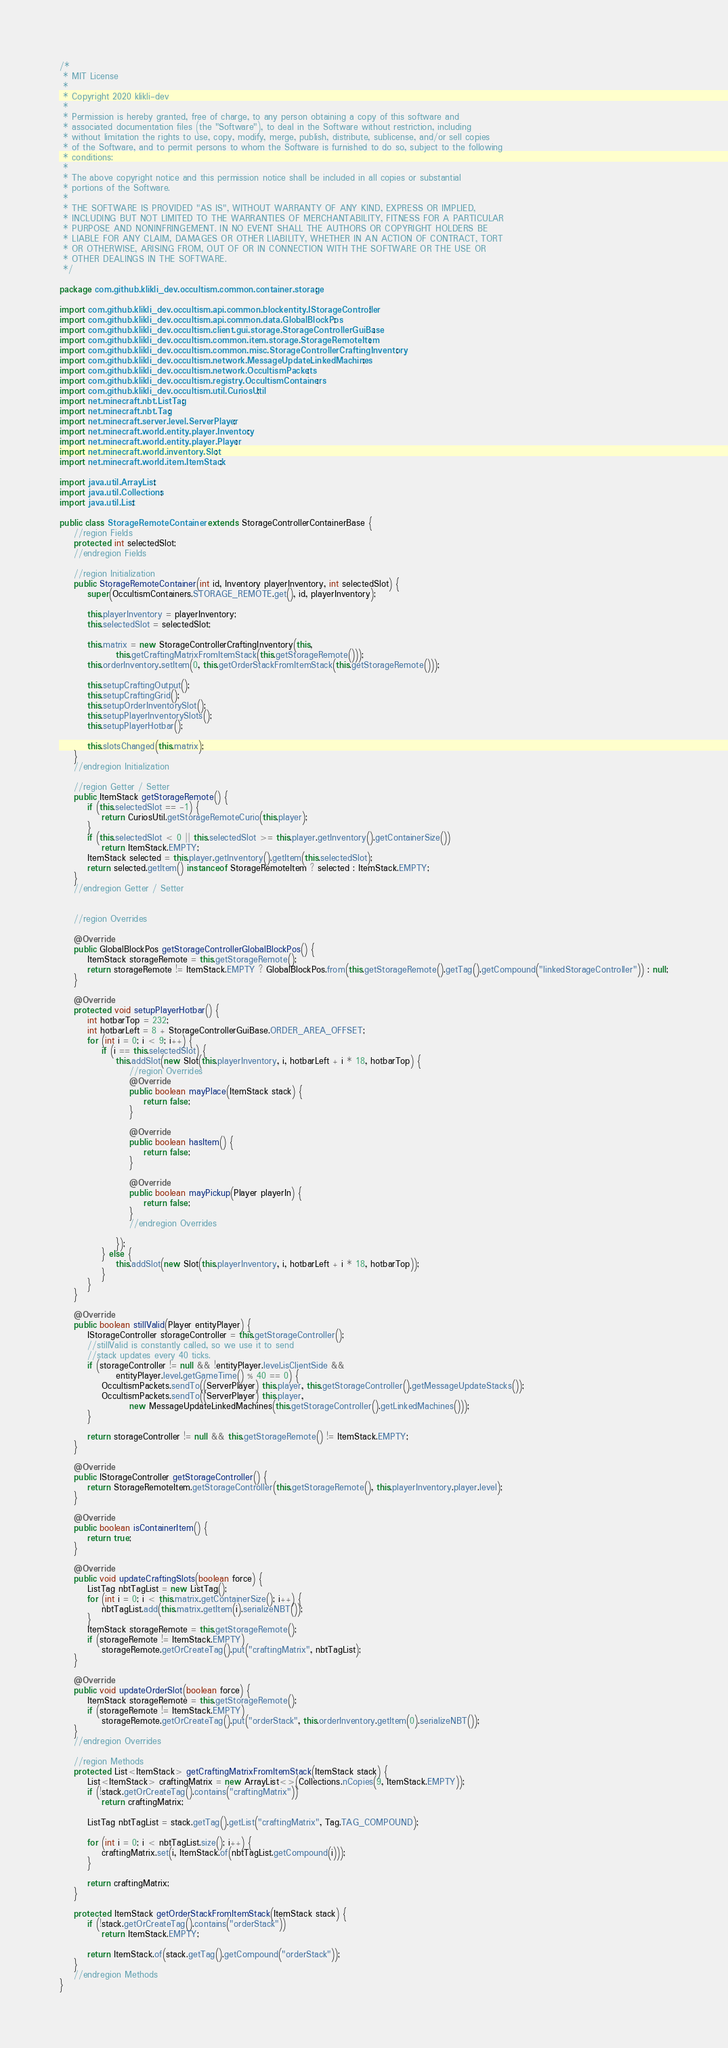<code> <loc_0><loc_0><loc_500><loc_500><_Java_>/*
 * MIT License
 *
 * Copyright 2020 klikli-dev
 *
 * Permission is hereby granted, free of charge, to any person obtaining a copy of this software and
 * associated documentation files (the "Software"), to deal in the Software without restriction, including
 * without limitation the rights to use, copy, modify, merge, publish, distribute, sublicense, and/or sell copies
 * of the Software, and to permit persons to whom the Software is furnished to do so, subject to the following
 * conditions:
 *
 * The above copyright notice and this permission notice shall be included in all copies or substantial
 * portions of the Software.
 *
 * THE SOFTWARE IS PROVIDED "AS IS", WITHOUT WARRANTY OF ANY KIND, EXPRESS OR IMPLIED,
 * INCLUDING BUT NOT LIMITED TO THE WARRANTIES OF MERCHANTABILITY, FITNESS FOR A PARTICULAR
 * PURPOSE AND NONINFRINGEMENT. IN NO EVENT SHALL THE AUTHORS OR COPYRIGHT HOLDERS BE
 * LIABLE FOR ANY CLAIM, DAMAGES OR OTHER LIABILITY, WHETHER IN AN ACTION OF CONTRACT, TORT
 * OR OTHERWISE, ARISING FROM, OUT OF OR IN CONNECTION WITH THE SOFTWARE OR THE USE OR
 * OTHER DEALINGS IN THE SOFTWARE.
 */

package com.github.klikli_dev.occultism.common.container.storage;

import com.github.klikli_dev.occultism.api.common.blockentity.IStorageController;
import com.github.klikli_dev.occultism.api.common.data.GlobalBlockPos;
import com.github.klikli_dev.occultism.client.gui.storage.StorageControllerGuiBase;
import com.github.klikli_dev.occultism.common.item.storage.StorageRemoteItem;
import com.github.klikli_dev.occultism.common.misc.StorageControllerCraftingInventory;
import com.github.klikli_dev.occultism.network.MessageUpdateLinkedMachines;
import com.github.klikli_dev.occultism.network.OccultismPackets;
import com.github.klikli_dev.occultism.registry.OccultismContainers;
import com.github.klikli_dev.occultism.util.CuriosUtil;
import net.minecraft.nbt.ListTag;
import net.minecraft.nbt.Tag;
import net.minecraft.server.level.ServerPlayer;
import net.minecraft.world.entity.player.Inventory;
import net.minecraft.world.entity.player.Player;
import net.minecraft.world.inventory.Slot;
import net.minecraft.world.item.ItemStack;

import java.util.ArrayList;
import java.util.Collections;
import java.util.List;

public class StorageRemoteContainer extends StorageControllerContainerBase {
    //region Fields
    protected int selectedSlot;
    //endregion Fields

    //region Initialization
    public StorageRemoteContainer(int id, Inventory playerInventory, int selectedSlot) {
        super(OccultismContainers.STORAGE_REMOTE.get(), id, playerInventory);

        this.playerInventory = playerInventory;
        this.selectedSlot = selectedSlot;

        this.matrix = new StorageControllerCraftingInventory(this,
                this.getCraftingMatrixFromItemStack(this.getStorageRemote()));
        this.orderInventory.setItem(0, this.getOrderStackFromItemStack(this.getStorageRemote()));

        this.setupCraftingOutput();
        this.setupCraftingGrid();
        this.setupOrderInventorySlot();
        this.setupPlayerInventorySlots();
        this.setupPlayerHotbar();

        this.slotsChanged(this.matrix);
    }
    //endregion Initialization

    //region Getter / Setter
    public ItemStack getStorageRemote() {
        if (this.selectedSlot == -1) {
            return CuriosUtil.getStorageRemoteCurio(this.player);
        }
        if (this.selectedSlot < 0 || this.selectedSlot >= this.player.getInventory().getContainerSize())
            return ItemStack.EMPTY;
        ItemStack selected = this.player.getInventory().getItem(this.selectedSlot);
        return selected.getItem() instanceof StorageRemoteItem ? selected : ItemStack.EMPTY;
    }
    //endregion Getter / Setter


    //region Overrides

    @Override
    public GlobalBlockPos getStorageControllerGlobalBlockPos() {
        ItemStack storageRemote = this.getStorageRemote();
        return storageRemote != ItemStack.EMPTY ? GlobalBlockPos.from(this.getStorageRemote().getTag().getCompound("linkedStorageController")) : null;
    }

    @Override
    protected void setupPlayerHotbar() {
        int hotbarTop = 232;
        int hotbarLeft = 8 + StorageControllerGuiBase.ORDER_AREA_OFFSET;
        for (int i = 0; i < 9; i++) {
            if (i == this.selectedSlot) {
                this.addSlot(new Slot(this.playerInventory, i, hotbarLeft + i * 18, hotbarTop) {
                    //region Overrides
                    @Override
                    public boolean mayPlace(ItemStack stack) {
                        return false;
                    }

                    @Override
                    public boolean hasItem() {
                        return false;
                    }

                    @Override
                    public boolean mayPickup(Player playerIn) {
                        return false;
                    }
                    //endregion Overrides

                });
            } else {
                this.addSlot(new Slot(this.playerInventory, i, hotbarLeft + i * 18, hotbarTop));
            }
        }
    }

    @Override
    public boolean stillValid(Player entityPlayer) {
        IStorageController storageController = this.getStorageController();
        //stillValid is constantly called, so we use it to send
        //stack updates every 40 ticks.
        if (storageController != null && !entityPlayer.level.isClientSide &&
                entityPlayer.level.getGameTime() % 40 == 0) {
            OccultismPackets.sendTo((ServerPlayer) this.player, this.getStorageController().getMessageUpdateStacks());
            OccultismPackets.sendTo((ServerPlayer) this.player,
                    new MessageUpdateLinkedMachines(this.getStorageController().getLinkedMachines()));
        }

        return storageController != null && this.getStorageRemote() != ItemStack.EMPTY;
    }

    @Override
    public IStorageController getStorageController() {
        return StorageRemoteItem.getStorageController(this.getStorageRemote(), this.playerInventory.player.level);
    }

    @Override
    public boolean isContainerItem() {
        return true;
    }

    @Override
    public void updateCraftingSlots(boolean force) {
        ListTag nbtTagList = new ListTag();
        for (int i = 0; i < this.matrix.getContainerSize(); i++) {
            nbtTagList.add(this.matrix.getItem(i).serializeNBT());
        }
        ItemStack storageRemote = this.getStorageRemote();
        if (storageRemote != ItemStack.EMPTY)
            storageRemote.getOrCreateTag().put("craftingMatrix", nbtTagList);
    }

    @Override
    public void updateOrderSlot(boolean force) {
        ItemStack storageRemote = this.getStorageRemote();
        if (storageRemote != ItemStack.EMPTY)
            storageRemote.getOrCreateTag().put("orderStack", this.orderInventory.getItem(0).serializeNBT());
    }
    //endregion Overrides

    //region Methods
    protected List<ItemStack> getCraftingMatrixFromItemStack(ItemStack stack) {
        List<ItemStack> craftingMatrix = new ArrayList<>(Collections.nCopies(9, ItemStack.EMPTY));
        if (!stack.getOrCreateTag().contains("craftingMatrix"))
            return craftingMatrix;

        ListTag nbtTagList = stack.getTag().getList("craftingMatrix", Tag.TAG_COMPOUND);

        for (int i = 0; i < nbtTagList.size(); i++) {
            craftingMatrix.set(i, ItemStack.of(nbtTagList.getCompound(i)));
        }

        return craftingMatrix;
    }

    protected ItemStack getOrderStackFromItemStack(ItemStack stack) {
        if (!stack.getOrCreateTag().contains("orderStack"))
            return ItemStack.EMPTY;

        return ItemStack.of(stack.getTag().getCompound("orderStack"));
    }
    //endregion Methods
}
</code> 